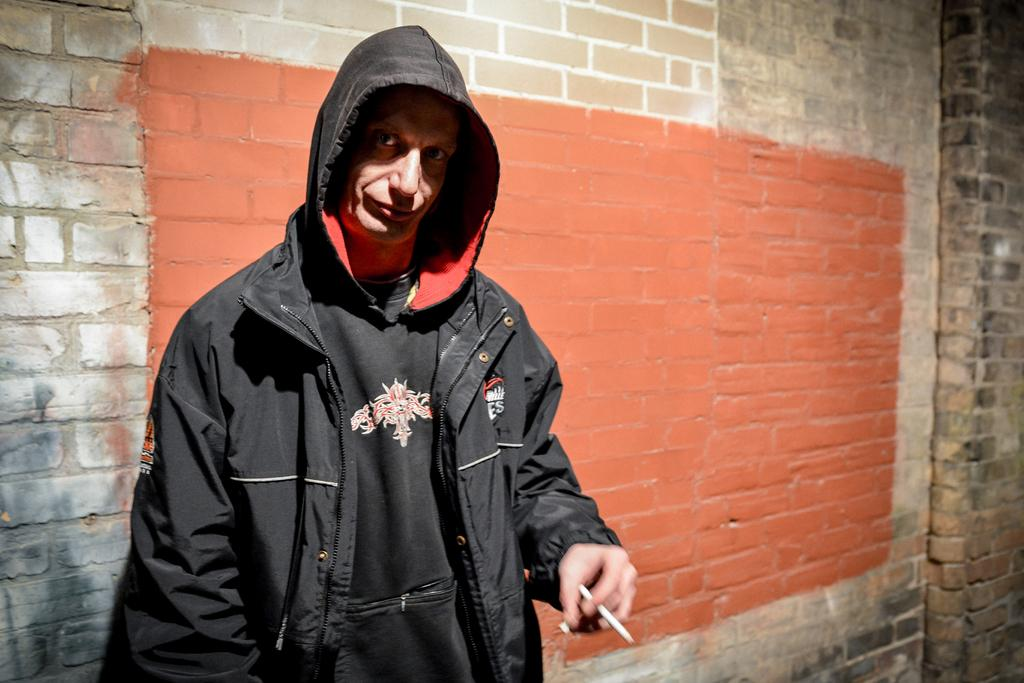What is the main subject in the image? There is a person standing in the front of the image. What is the person holding in the image? The person is holding an object. What can be seen in the background of the image? There is a wall in the background of the image. How many cows are visible in the image? There are no cows present in the image. What type of cabbage is the person holding in the image? The person is not holding a cabbage in the image; they are holding an unspecified object. 